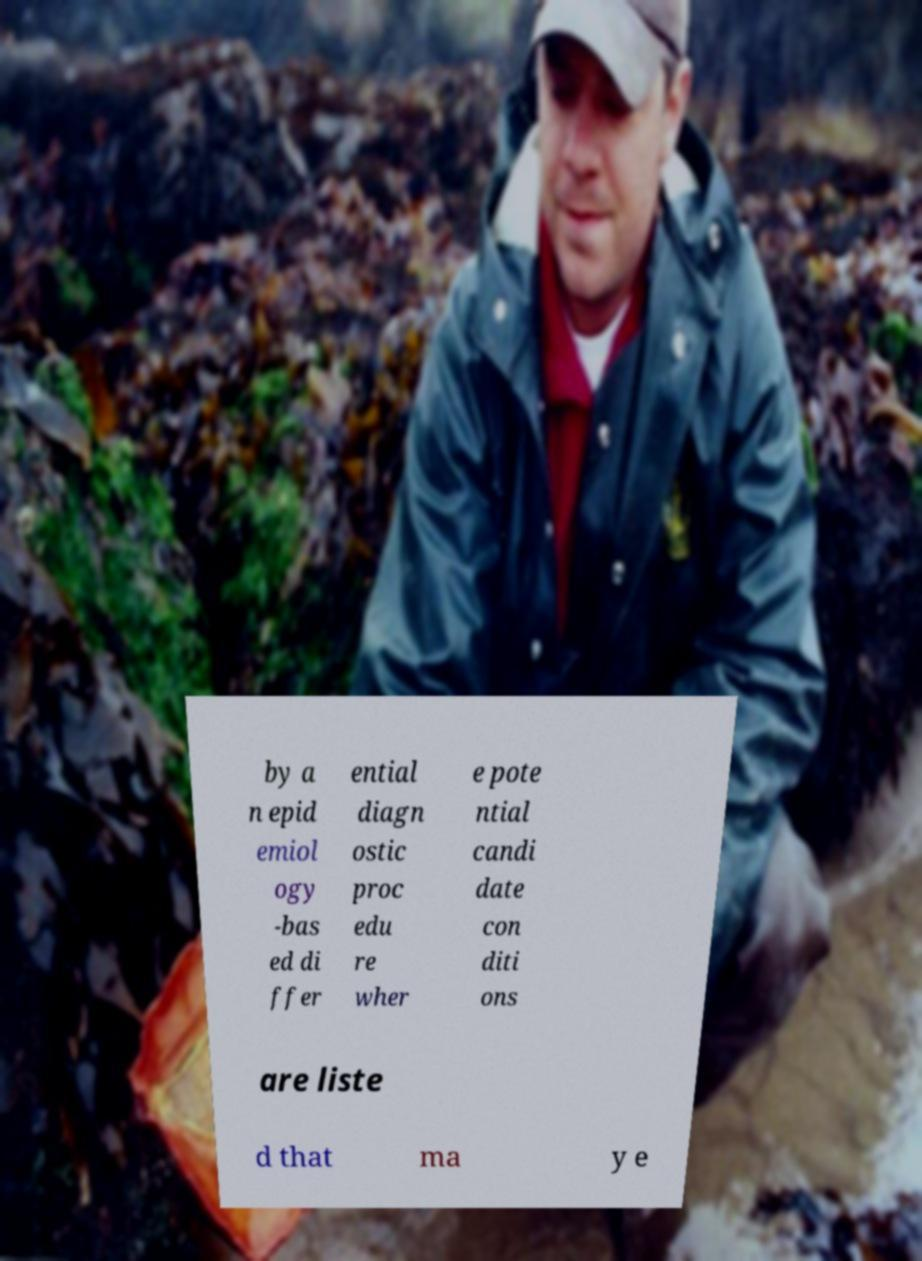Can you read and provide the text displayed in the image?This photo seems to have some interesting text. Can you extract and type it out for me? by a n epid emiol ogy -bas ed di ffer ential diagn ostic proc edu re wher e pote ntial candi date con diti ons are liste d that ma y e 